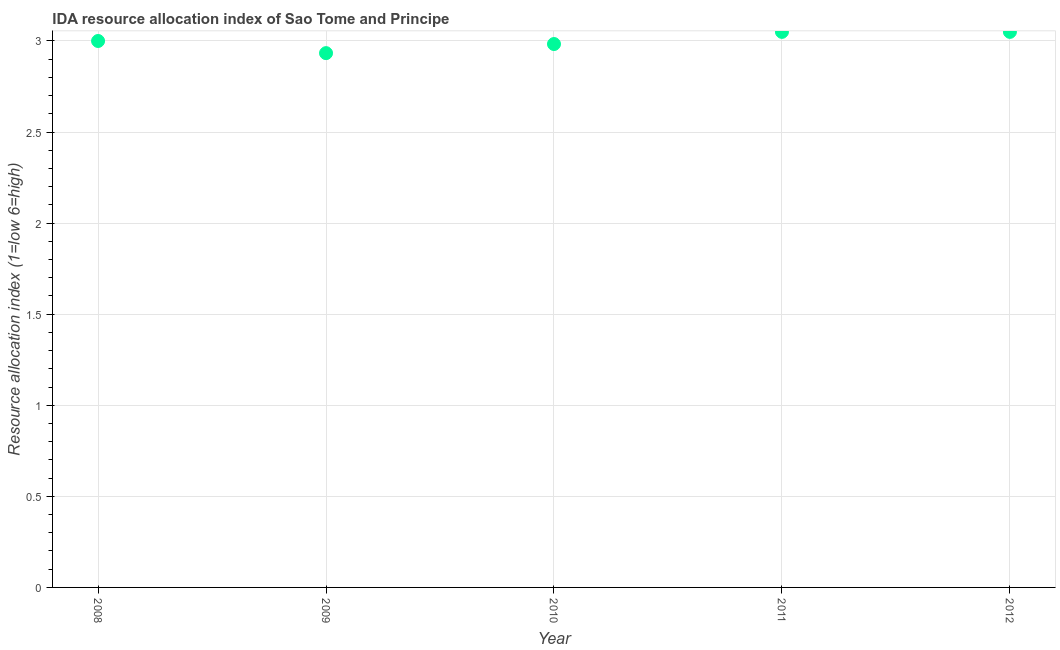What is the ida resource allocation index in 2011?
Your answer should be very brief. 3.05. Across all years, what is the maximum ida resource allocation index?
Keep it short and to the point. 3.05. Across all years, what is the minimum ida resource allocation index?
Your answer should be very brief. 2.93. In which year was the ida resource allocation index maximum?
Your answer should be very brief. 2011. What is the sum of the ida resource allocation index?
Make the answer very short. 15.02. What is the difference between the ida resource allocation index in 2008 and 2011?
Ensure brevity in your answer.  -0.05. What is the average ida resource allocation index per year?
Offer a very short reply. 3. Do a majority of the years between 2011 and 2010 (inclusive) have ida resource allocation index greater than 2.9 ?
Ensure brevity in your answer.  No. What is the ratio of the ida resource allocation index in 2009 to that in 2011?
Offer a very short reply. 0.96. Is the ida resource allocation index in 2008 less than that in 2009?
Make the answer very short. No. Is the difference between the ida resource allocation index in 2009 and 2012 greater than the difference between any two years?
Your answer should be very brief. Yes. What is the difference between the highest and the second highest ida resource allocation index?
Your answer should be very brief. 0. Is the sum of the ida resource allocation index in 2008 and 2010 greater than the maximum ida resource allocation index across all years?
Give a very brief answer. Yes. What is the difference between the highest and the lowest ida resource allocation index?
Keep it short and to the point. 0.12. Does the ida resource allocation index monotonically increase over the years?
Ensure brevity in your answer.  No. How many dotlines are there?
Your answer should be compact. 1. How many years are there in the graph?
Offer a very short reply. 5. Does the graph contain any zero values?
Give a very brief answer. No. What is the title of the graph?
Your answer should be very brief. IDA resource allocation index of Sao Tome and Principe. What is the label or title of the Y-axis?
Your answer should be compact. Resource allocation index (1=low 6=high). What is the Resource allocation index (1=low 6=high) in 2008?
Your answer should be very brief. 3. What is the Resource allocation index (1=low 6=high) in 2009?
Provide a short and direct response. 2.93. What is the Resource allocation index (1=low 6=high) in 2010?
Make the answer very short. 2.98. What is the Resource allocation index (1=low 6=high) in 2011?
Make the answer very short. 3.05. What is the Resource allocation index (1=low 6=high) in 2012?
Make the answer very short. 3.05. What is the difference between the Resource allocation index (1=low 6=high) in 2008 and 2009?
Your answer should be compact. 0.07. What is the difference between the Resource allocation index (1=low 6=high) in 2008 and 2010?
Ensure brevity in your answer.  0.02. What is the difference between the Resource allocation index (1=low 6=high) in 2008 and 2011?
Provide a succinct answer. -0.05. What is the difference between the Resource allocation index (1=low 6=high) in 2009 and 2010?
Offer a very short reply. -0.05. What is the difference between the Resource allocation index (1=low 6=high) in 2009 and 2011?
Keep it short and to the point. -0.12. What is the difference between the Resource allocation index (1=low 6=high) in 2009 and 2012?
Provide a succinct answer. -0.12. What is the difference between the Resource allocation index (1=low 6=high) in 2010 and 2011?
Your response must be concise. -0.07. What is the difference between the Resource allocation index (1=low 6=high) in 2010 and 2012?
Your response must be concise. -0.07. What is the ratio of the Resource allocation index (1=low 6=high) in 2008 to that in 2009?
Your answer should be compact. 1.02. What is the ratio of the Resource allocation index (1=low 6=high) in 2009 to that in 2010?
Your answer should be very brief. 0.98. What is the ratio of the Resource allocation index (1=low 6=high) in 2009 to that in 2011?
Your answer should be very brief. 0.96. What is the ratio of the Resource allocation index (1=low 6=high) in 2010 to that in 2011?
Ensure brevity in your answer.  0.98. 